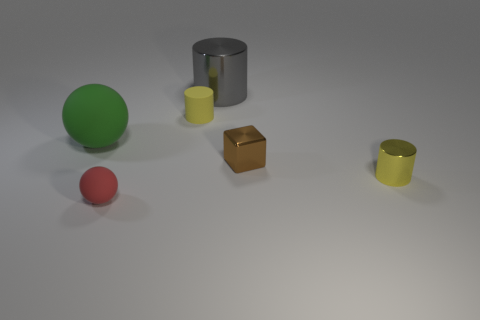Are there any small green metallic things of the same shape as the brown metallic thing?
Provide a short and direct response. No. There is a matte sphere that is the same size as the rubber cylinder; what is its color?
Your answer should be very brief. Red. How many objects are matte objects that are in front of the brown block or metal things that are in front of the tiny rubber cylinder?
Your answer should be very brief. 3. How many objects are either gray cylinders or big brown metal balls?
Your answer should be compact. 1. What is the size of the object that is in front of the shiny block and to the right of the big gray cylinder?
Your response must be concise. Small. What number of tiny things have the same material as the red sphere?
Make the answer very short. 1. There is a tiny cylinder that is made of the same material as the red object; what color is it?
Make the answer very short. Yellow. Do the large object to the right of the green matte thing and the large rubber object have the same color?
Offer a very short reply. No. There is a small cylinder right of the cube; what material is it?
Offer a very short reply. Metal. Is the number of small yellow things in front of the cube the same as the number of big blue spheres?
Your answer should be compact. No. 